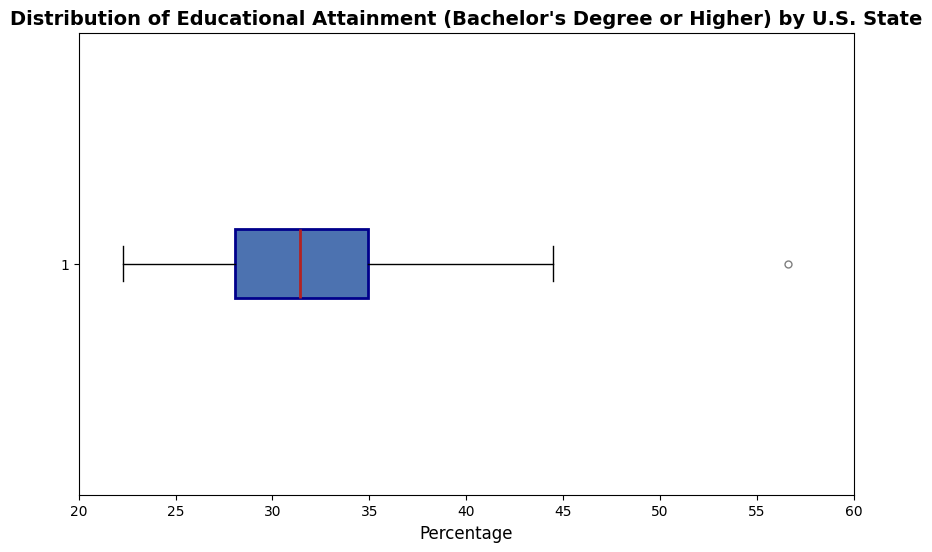What's the median percentage of people with a Bachelor's degree or higher in U.S. states? The median value on a box plot is indicated by the line inside the box. Referring to the box plot, identify this value.
Answer: Around 30% Which state is an outlier with the highest percentage of Bachelor's degrees or higher? On a box plot, outliers are typically represented as points beyond the whiskers. The outlier on the far right represents the state with the highest value.
Answer: District of Columbia Compare the interquartile range (IQR) of the data to the range of the whiskers. The interquartile range (IQR) is the distance between the lower quartile (25th percentile) and the upper quartile (75th percentile), represented by the box's left and right edges. The whiskers usually extend to 1.5 times the IQR from the quartiles or to the minimum/maximum data points within that range. Compare these distances visually.
Answer: The whiskers extend beyond the IQR, indicating they capture more spread in the data What is the range of percentages within the box? The lower edge of the box represents the 25th percentile, and the upper edge represents the 75th percentile. Subtract the lower value from the upper value to get the range.
Answer: Approximately 27% to 38% How many states fall below the lower quartile? The lower quartile represents the 25th percentile. Count the states that fall below this value from the box plot.
Answer: Around 12-13 states What does the height of the outliers denote in the box plot? The height of the outlier points marks their actual percentage values for states with unusually high or low educational attainment levels.
Answer: Outlier values Is there a significant spread in the data, and how can you tell? The spread can be interpreted by looking at the distance between the whiskers and the box. A large distance indicates a significant spread, whereas a small distance indicates a more uniform distribution.
Answer: Yes, indicated by the wide span of the whiskers and the box 